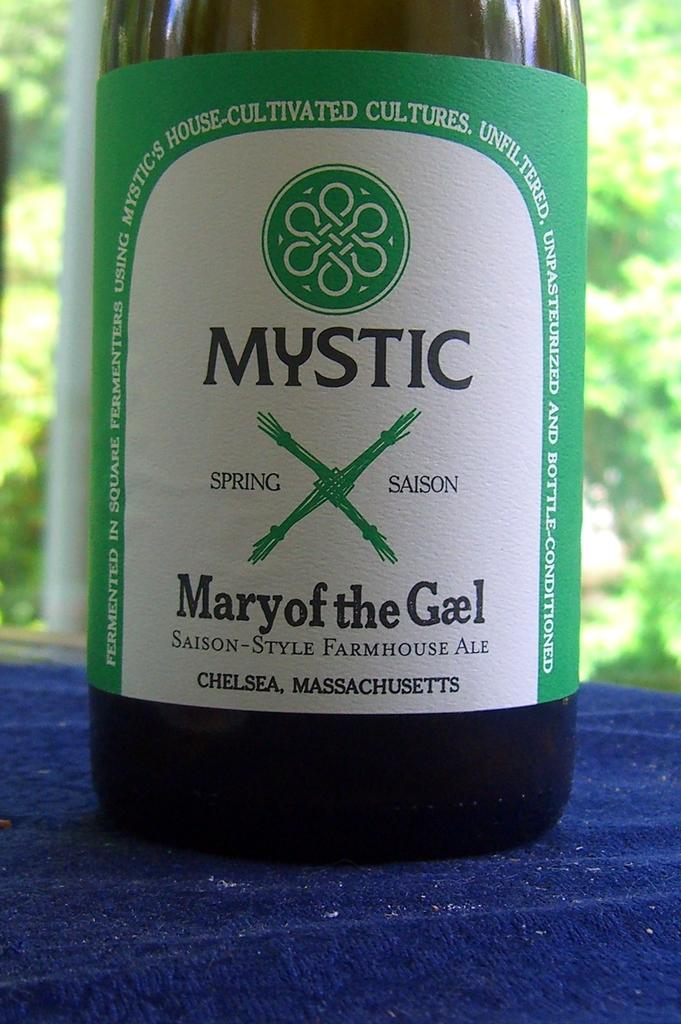<image>
Write a terse but informative summary of the picture. A bottle of Mystic brand ale with a green and white label. 